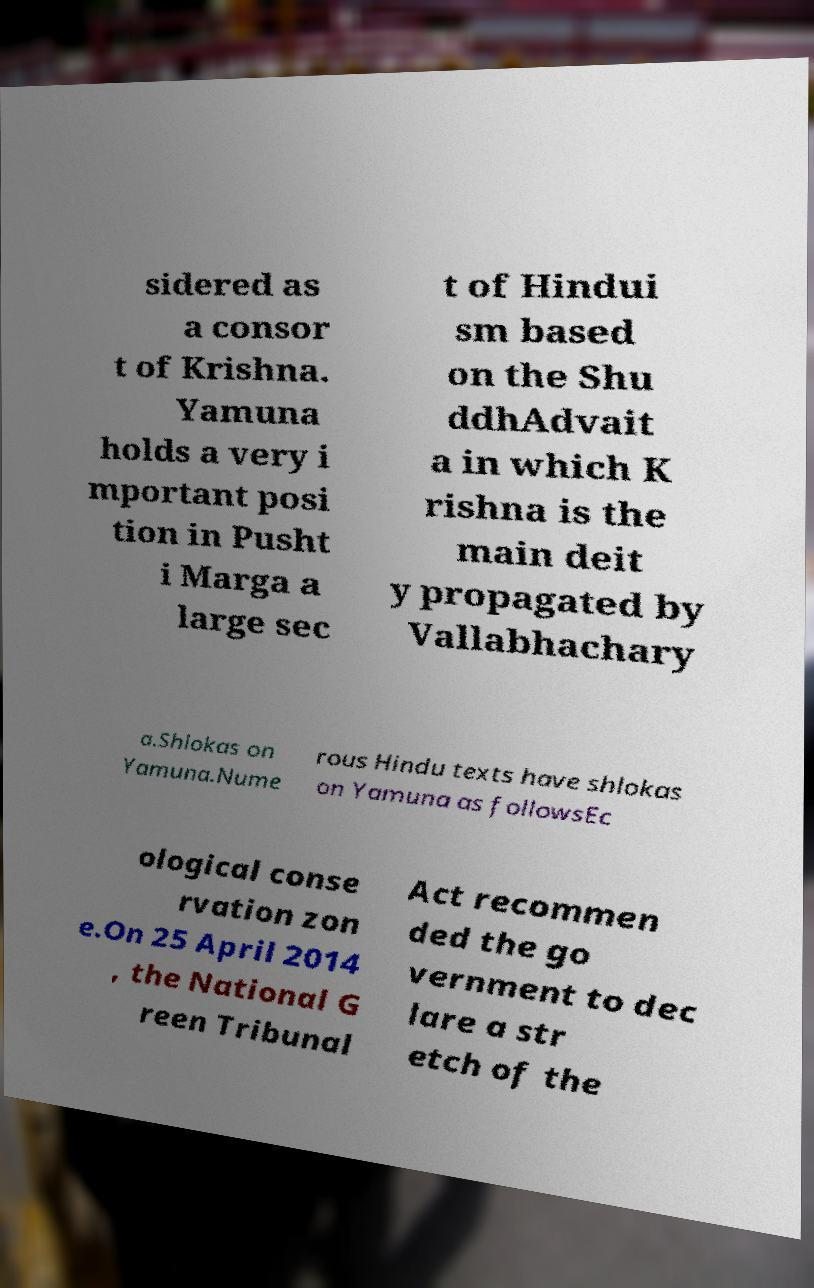Please read and relay the text visible in this image. What does it say? sidered as a consor t of Krishna. Yamuna holds a very i mportant posi tion in Pusht i Marga a large sec t of Hindui sm based on the Shu ddhAdvait a in which K rishna is the main deit y propagated by Vallabhachary a.Shlokas on Yamuna.Nume rous Hindu texts have shlokas on Yamuna as followsEc ological conse rvation zon e.On 25 April 2014 , the National G reen Tribunal Act recommen ded the go vernment to dec lare a str etch of the 